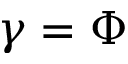Convert formula to latex. <formula><loc_0><loc_0><loc_500><loc_500>\gamma = \Phi</formula> 